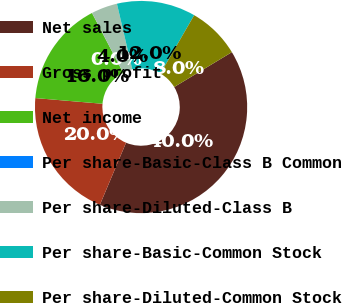<chart> <loc_0><loc_0><loc_500><loc_500><pie_chart><fcel>Net sales<fcel>Gross profit<fcel>Net income<fcel>Per share-Basic-Class B Common<fcel>Per share-Diluted-Class B<fcel>Per share-Basic-Common Stock<fcel>Per share-Diluted-Common Stock<nl><fcel>40.0%<fcel>20.0%<fcel>16.0%<fcel>0.0%<fcel>4.0%<fcel>12.0%<fcel>8.0%<nl></chart> 